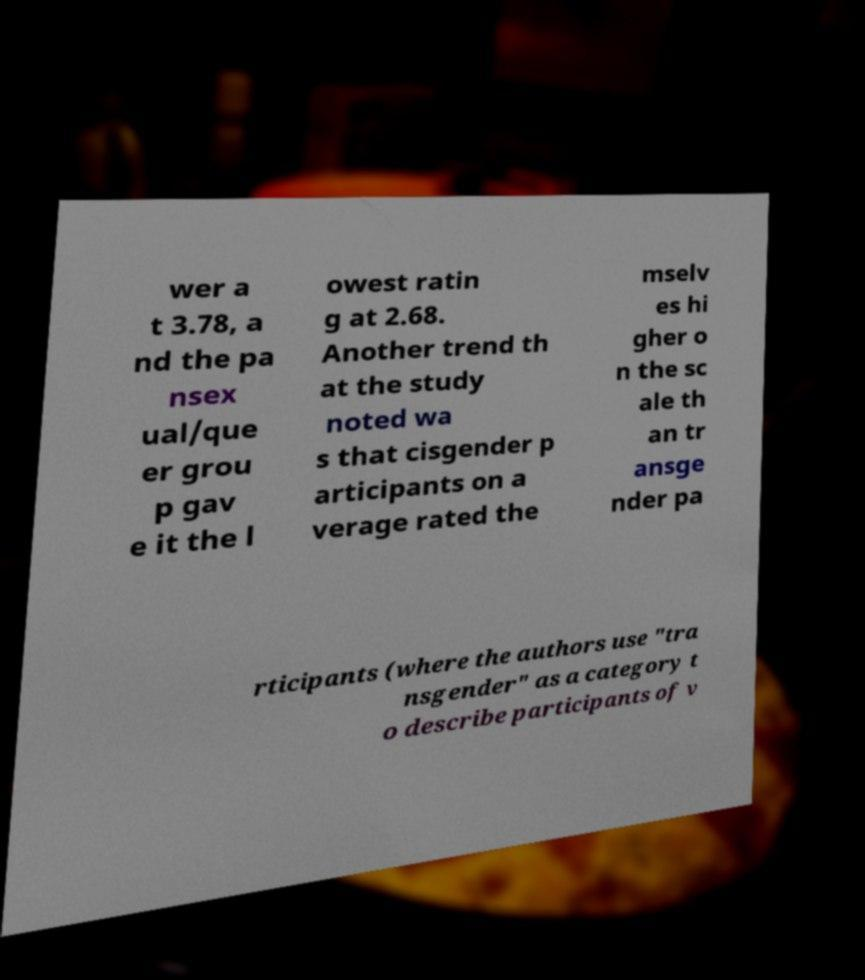I need the written content from this picture converted into text. Can you do that? wer a t 3.78, a nd the pa nsex ual/que er grou p gav e it the l owest ratin g at 2.68. Another trend th at the study noted wa s that cisgender p articipants on a verage rated the mselv es hi gher o n the sc ale th an tr ansge nder pa rticipants (where the authors use "tra nsgender" as a category t o describe participants of v 